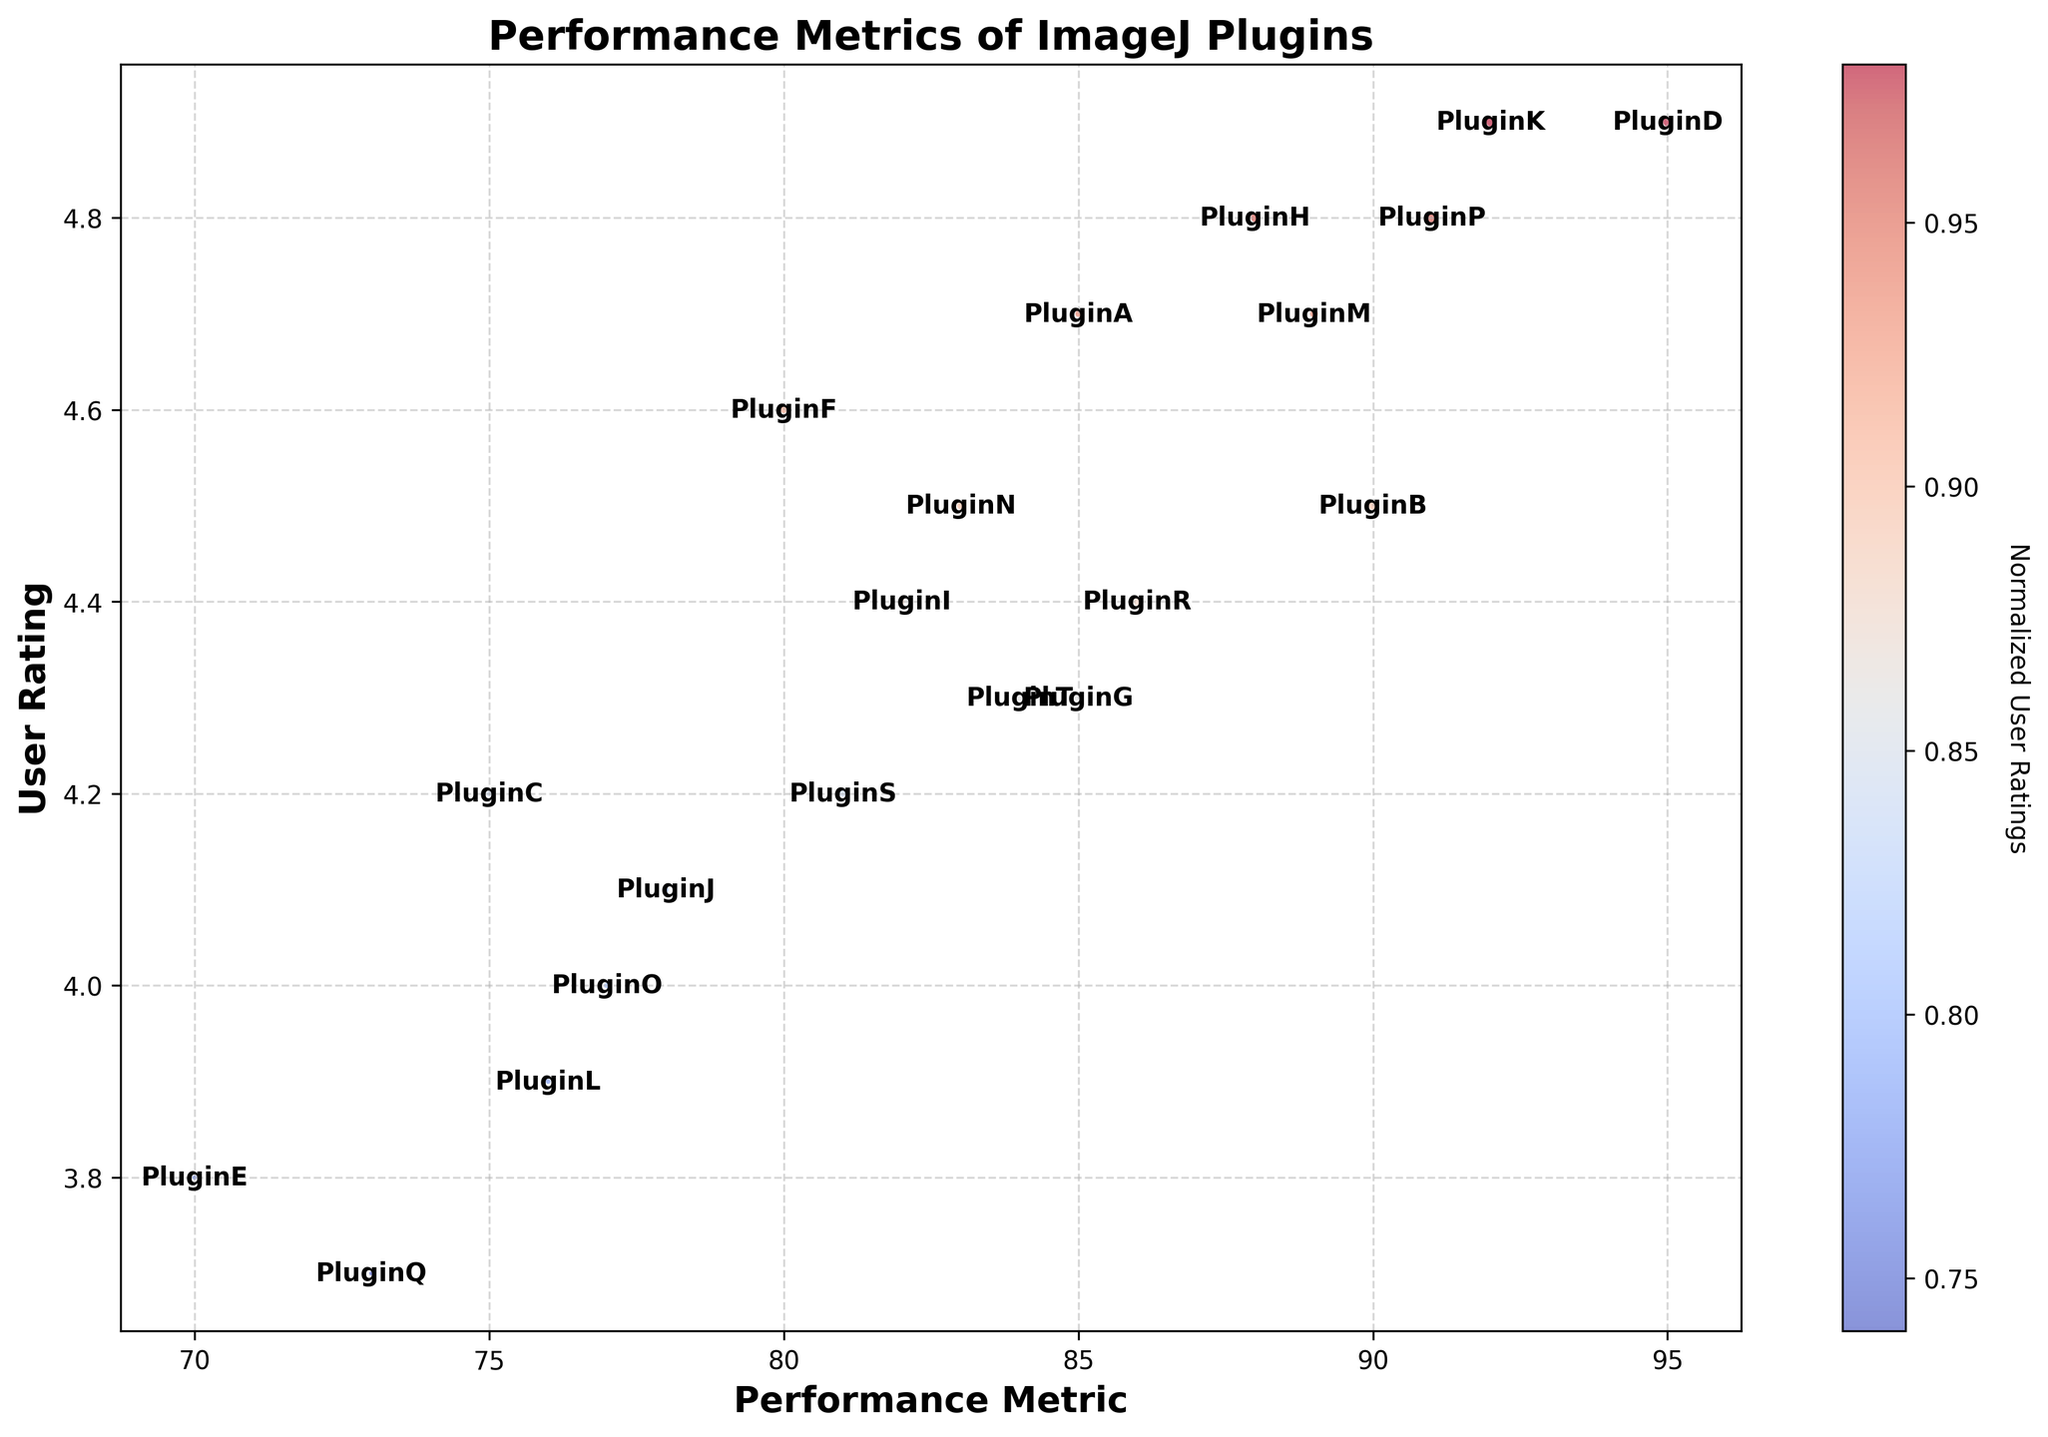Which plugin has the highest user rating? First, identify the highest point on the y-axis representing the user rating. The plugin at this point is PluginD and PluginK, both with a user rating of 4.9.
Answer: PluginD, PluginK How many plugins have a performance metric greater than 90? Count the number of plugins with a performance metric value above 90 on the x-axis. Plugins B, D, K, and P meet this criterion.
Answer: 4 Which plugin has the largest bubble size, and what does it represent? The largest bubble represents the number of downloads. By comparing bubble sizes visually, the largest bubble corresponds to PluginP, which has the maximum number of downloads (32,000).
Answer: PluginP What is the average user rating of plugins with a performance metric less than 80? Identify plugins with a performance metric less than 80 (Plugins C, E, L, O, Q, J). Sum their user ratings (4.2 + 3.8 + 3.9 + 4.0 + 3.7 + 4.1 = 23.7) and divide by the number of these plugins (6) to find the average (23.7/6 ≈ 3.95).
Answer: 3.95 Which two plugins have the closest performance metrics to 85, and how do their user ratings compare? Find the plugins with performance metrics closest to 85, which are PluginA and PluginG with exactly 85. Compare their user ratings: 4.7 (PluginA) and 4.3 (PluginG).
Answer: PluginA has a higher user rating What are the total number of downloads for plugins with a user rating of 4.8 or higher? Identify plugins with a user rating of 4.8 or higher (Plugins D, H, K, P). Sum their number of downloads (30,000 + 27,000 + 31,000 + 32,000 = 120,000).
Answer: 120,000 Which plugin with a performance metric between 80 and 90 has the smallest bubble size? Identify plugins with performance metrics between 80 and 90 (Plugins A, G, H, I, N, R, S, T), then compare their bubble sizes (number of downloads) to find the smallest, which is PluginI with 16,000 downloads.
Answer: PluginI Which plugin has the same performance metric as PluginR but a higher user rating? PluginR has a performance metric of 86 and a user rating of 4.4. Compare it to other plugins with the same performance metric; there are none. Thus, no plugin fits both criteria.
Answer: None What is the difference in user ratings between the plugins with the highest and lowest performance metrics? Identify the plugins with the highest (PluginP with 91) and lowest (PluginQ with 73) performance metrics. Subtract their user ratings (4.8 - 3.7 = 1.1).
Answer: 1.1 